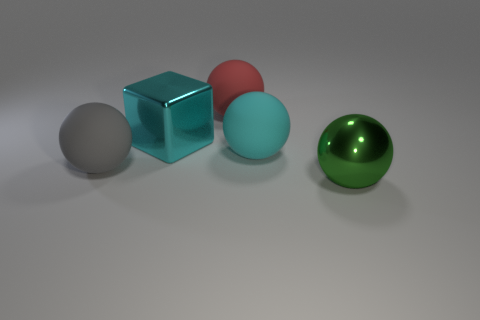Can you describe the lighting in the scene? The lighting appears to be diffuse, with a softer shadow cast under each object, indicating an overhead, probably ambient light source. There are no harsh shadows or bright spots, which suggests that the scene is evenly lit. 